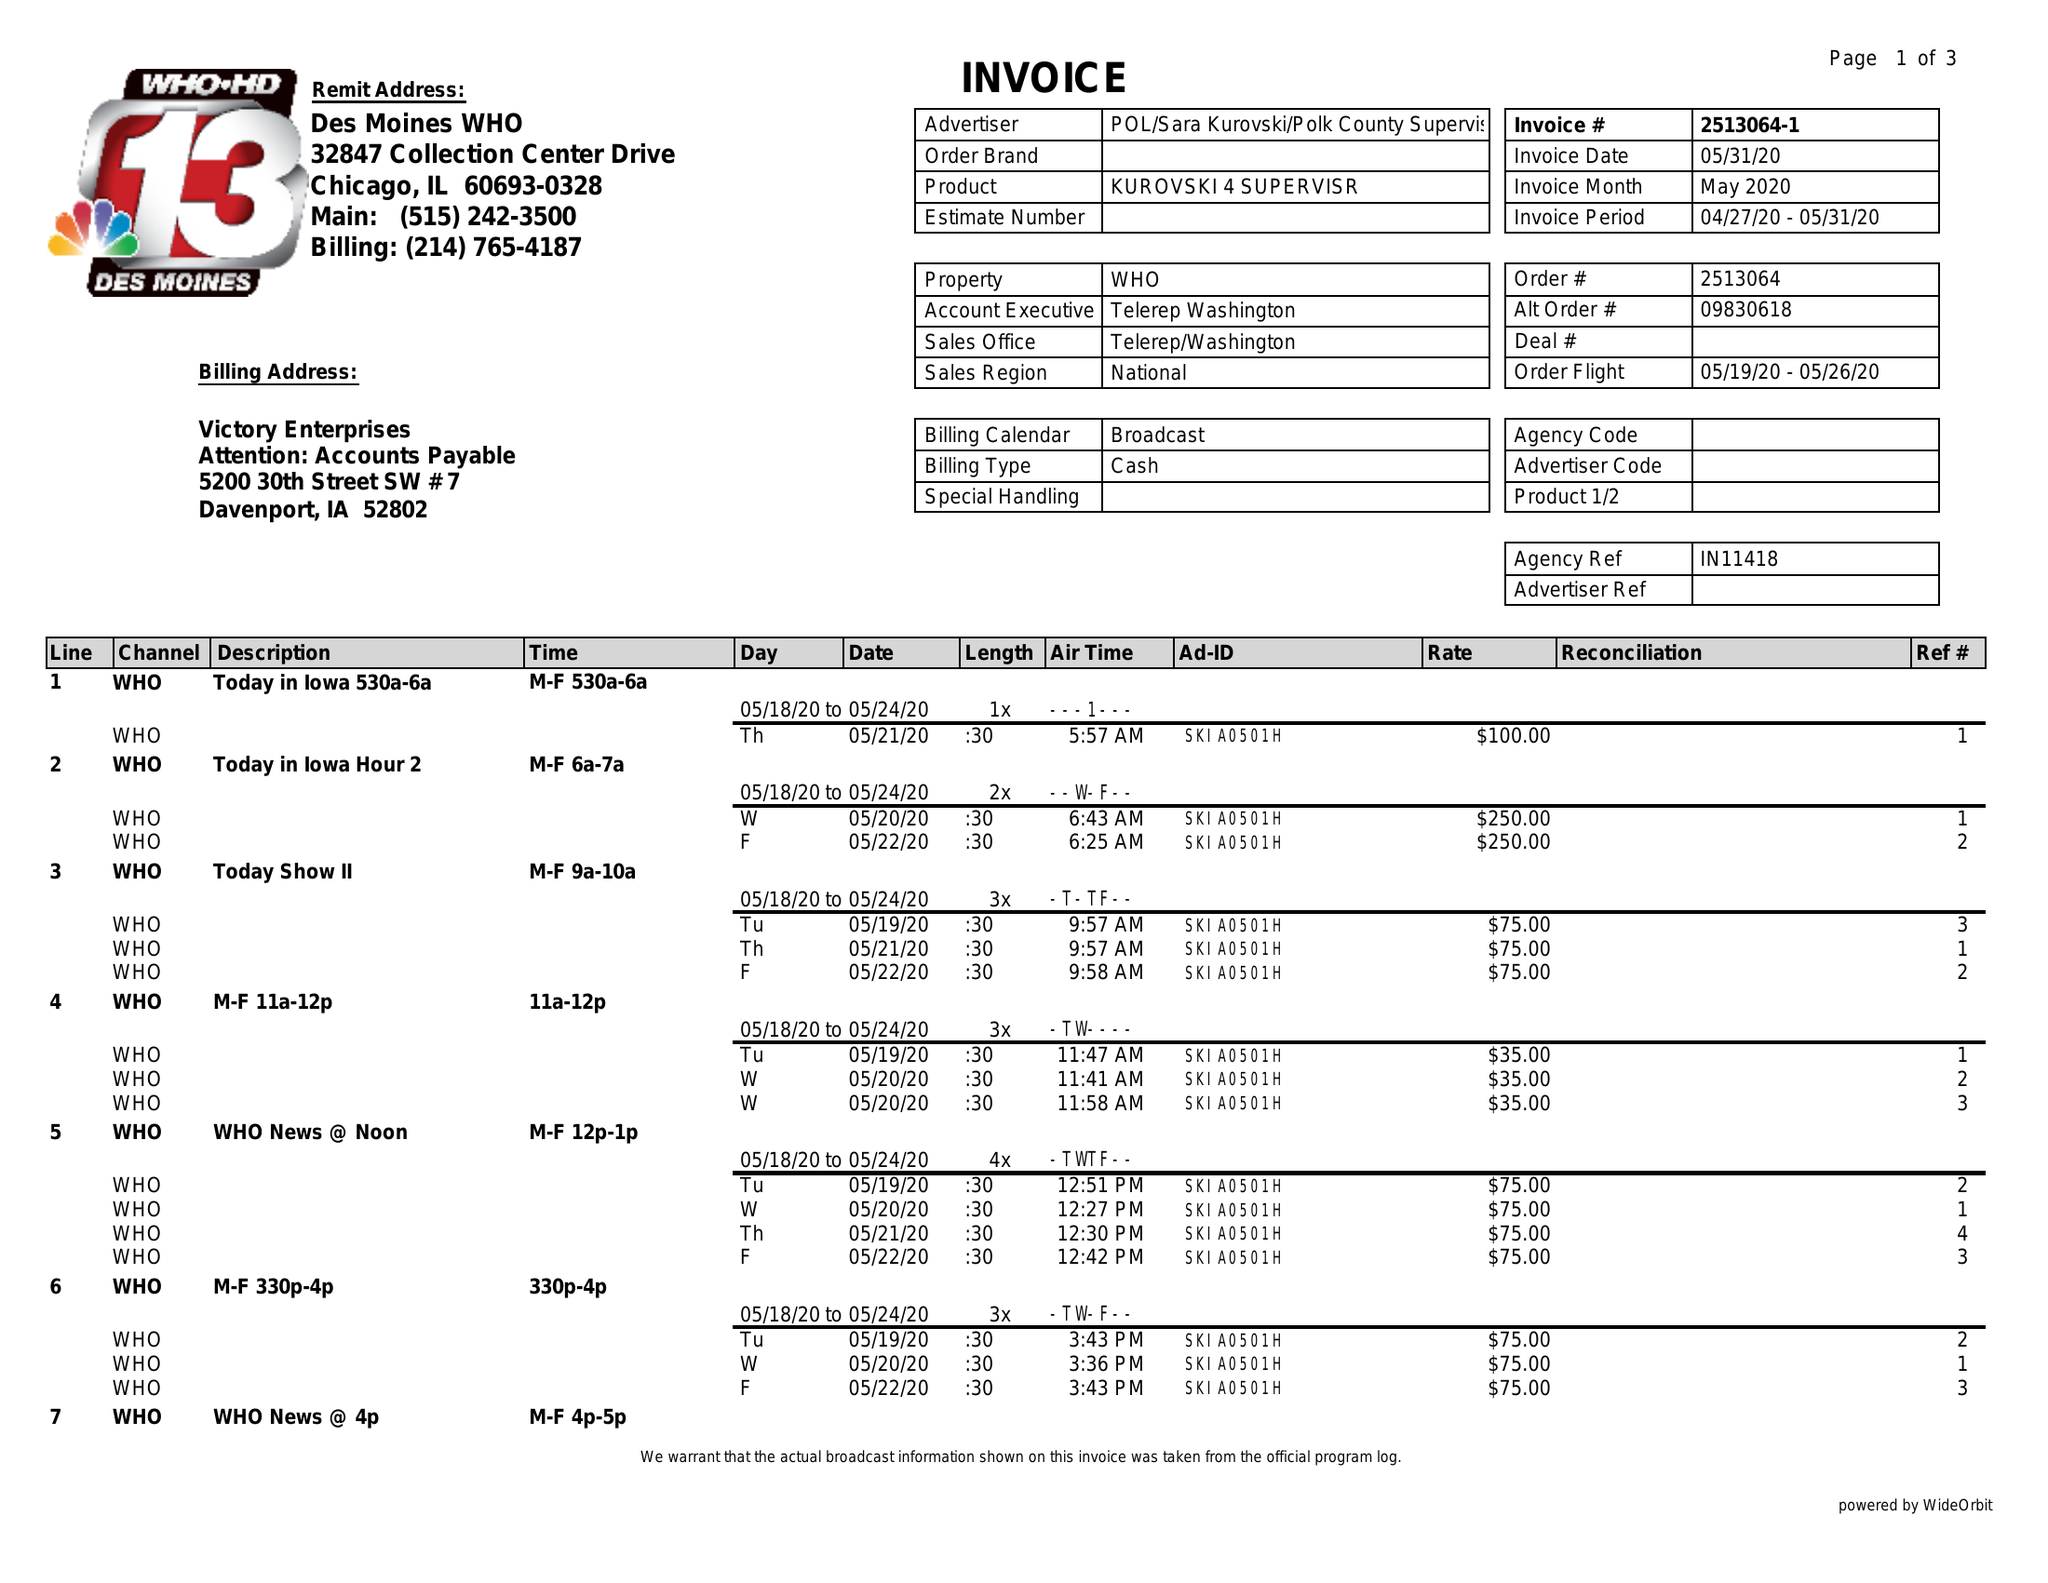What is the value for the advertiser?
Answer the question using a single word or phrase. POL/SARAKUROVSKI/POLKCOUNTYSUPERVISOR 